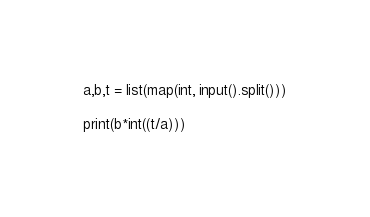<code> <loc_0><loc_0><loc_500><loc_500><_Python_>a,b,t = list(map(int, input().split()))

print(b*int((t/a)))</code> 